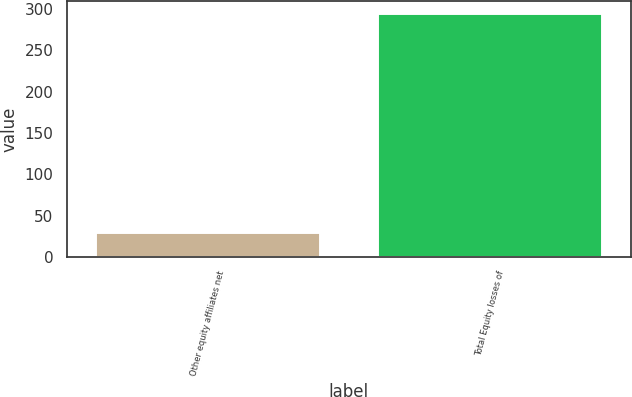Convert chart to OTSL. <chart><loc_0><loc_0><loc_500><loc_500><bar_chart><fcel>Other equity affiliates net<fcel>Total Equity losses of<nl><fcel>30<fcel>295<nl></chart> 